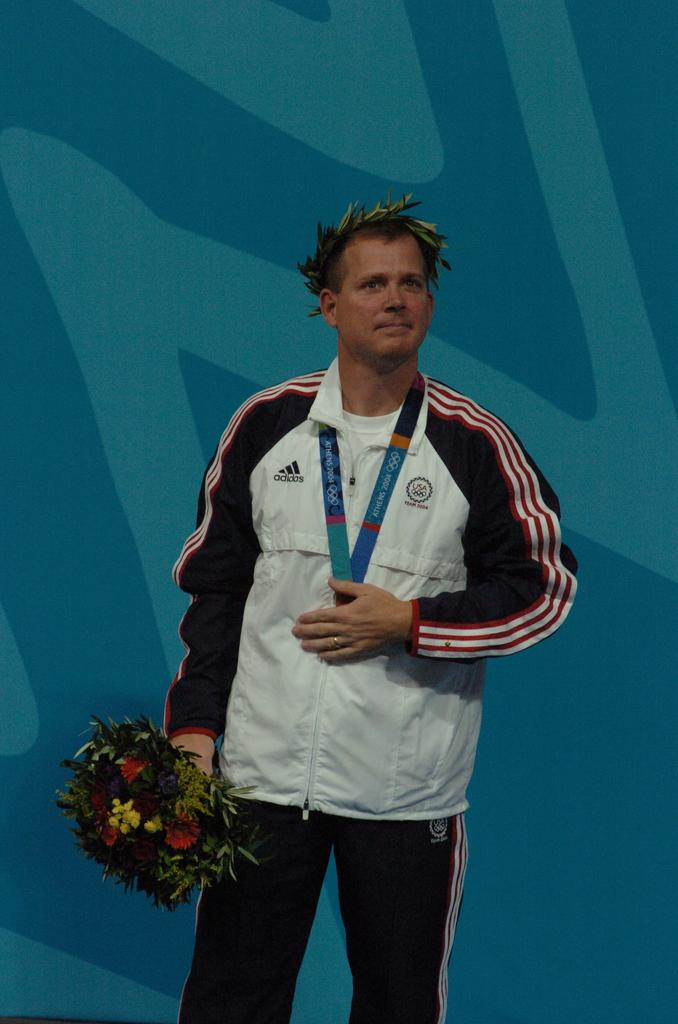<image>
Offer a succinct explanation of the picture presented. Man from Team USA wearing a medal and standing proudly. 